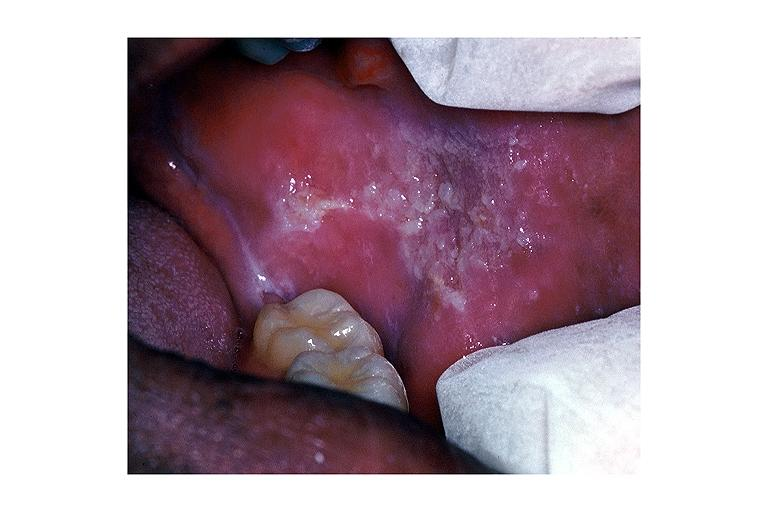does excellent example case show leukoplakia?
Answer the question using a single word or phrase. No 